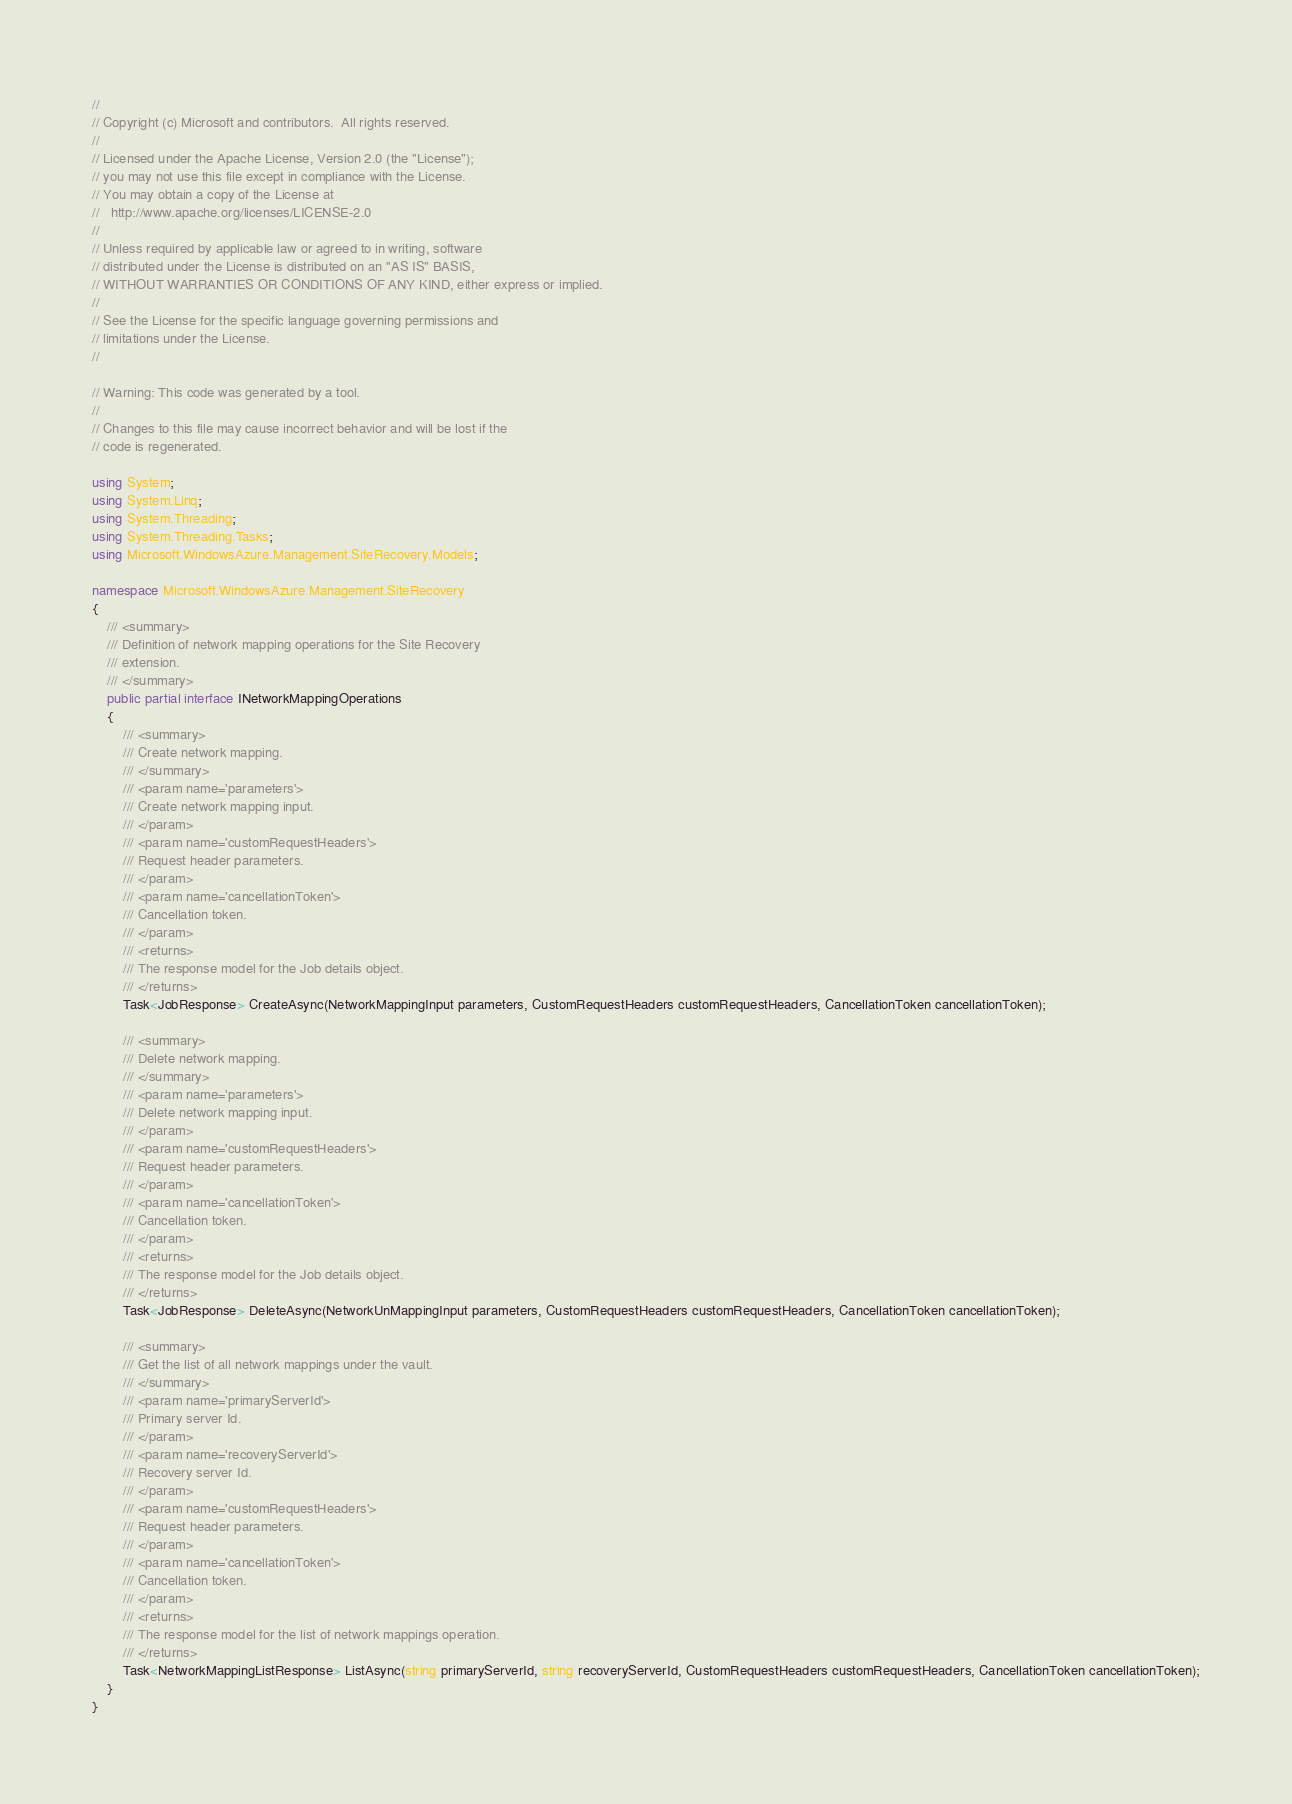Convert code to text. <code><loc_0><loc_0><loc_500><loc_500><_C#_>// 
// Copyright (c) Microsoft and contributors.  All rights reserved.
// 
// Licensed under the Apache License, Version 2.0 (the "License");
// you may not use this file except in compliance with the License.
// You may obtain a copy of the License at
//   http://www.apache.org/licenses/LICENSE-2.0
// 
// Unless required by applicable law or agreed to in writing, software
// distributed under the License is distributed on an "AS IS" BASIS,
// WITHOUT WARRANTIES OR CONDITIONS OF ANY KIND, either express or implied.
// 
// See the License for the specific language governing permissions and
// limitations under the License.
// 

// Warning: This code was generated by a tool.
// 
// Changes to this file may cause incorrect behavior and will be lost if the
// code is regenerated.

using System;
using System.Linq;
using System.Threading;
using System.Threading.Tasks;
using Microsoft.WindowsAzure.Management.SiteRecovery.Models;

namespace Microsoft.WindowsAzure.Management.SiteRecovery
{
    /// <summary>
    /// Definition of network mapping operations for the Site Recovery
    /// extension.
    /// </summary>
    public partial interface INetworkMappingOperations
    {
        /// <summary>
        /// Create network mapping.
        /// </summary>
        /// <param name='parameters'>
        /// Create network mapping input.
        /// </param>
        /// <param name='customRequestHeaders'>
        /// Request header parameters.
        /// </param>
        /// <param name='cancellationToken'>
        /// Cancellation token.
        /// </param>
        /// <returns>
        /// The response model for the Job details object.
        /// </returns>
        Task<JobResponse> CreateAsync(NetworkMappingInput parameters, CustomRequestHeaders customRequestHeaders, CancellationToken cancellationToken);
        
        /// <summary>
        /// Delete network mapping.
        /// </summary>
        /// <param name='parameters'>
        /// Delete network mapping input.
        /// </param>
        /// <param name='customRequestHeaders'>
        /// Request header parameters.
        /// </param>
        /// <param name='cancellationToken'>
        /// Cancellation token.
        /// </param>
        /// <returns>
        /// The response model for the Job details object.
        /// </returns>
        Task<JobResponse> DeleteAsync(NetworkUnMappingInput parameters, CustomRequestHeaders customRequestHeaders, CancellationToken cancellationToken);
        
        /// <summary>
        /// Get the list of all network mappings under the vault.
        /// </summary>
        /// <param name='primaryServerId'>
        /// Primary server Id.
        /// </param>
        /// <param name='recoveryServerId'>
        /// Recovery server Id.
        /// </param>
        /// <param name='customRequestHeaders'>
        /// Request header parameters.
        /// </param>
        /// <param name='cancellationToken'>
        /// Cancellation token.
        /// </param>
        /// <returns>
        /// The response model for the list of network mappings operation.
        /// </returns>
        Task<NetworkMappingListResponse> ListAsync(string primaryServerId, string recoveryServerId, CustomRequestHeaders customRequestHeaders, CancellationToken cancellationToken);
    }
}
</code> 